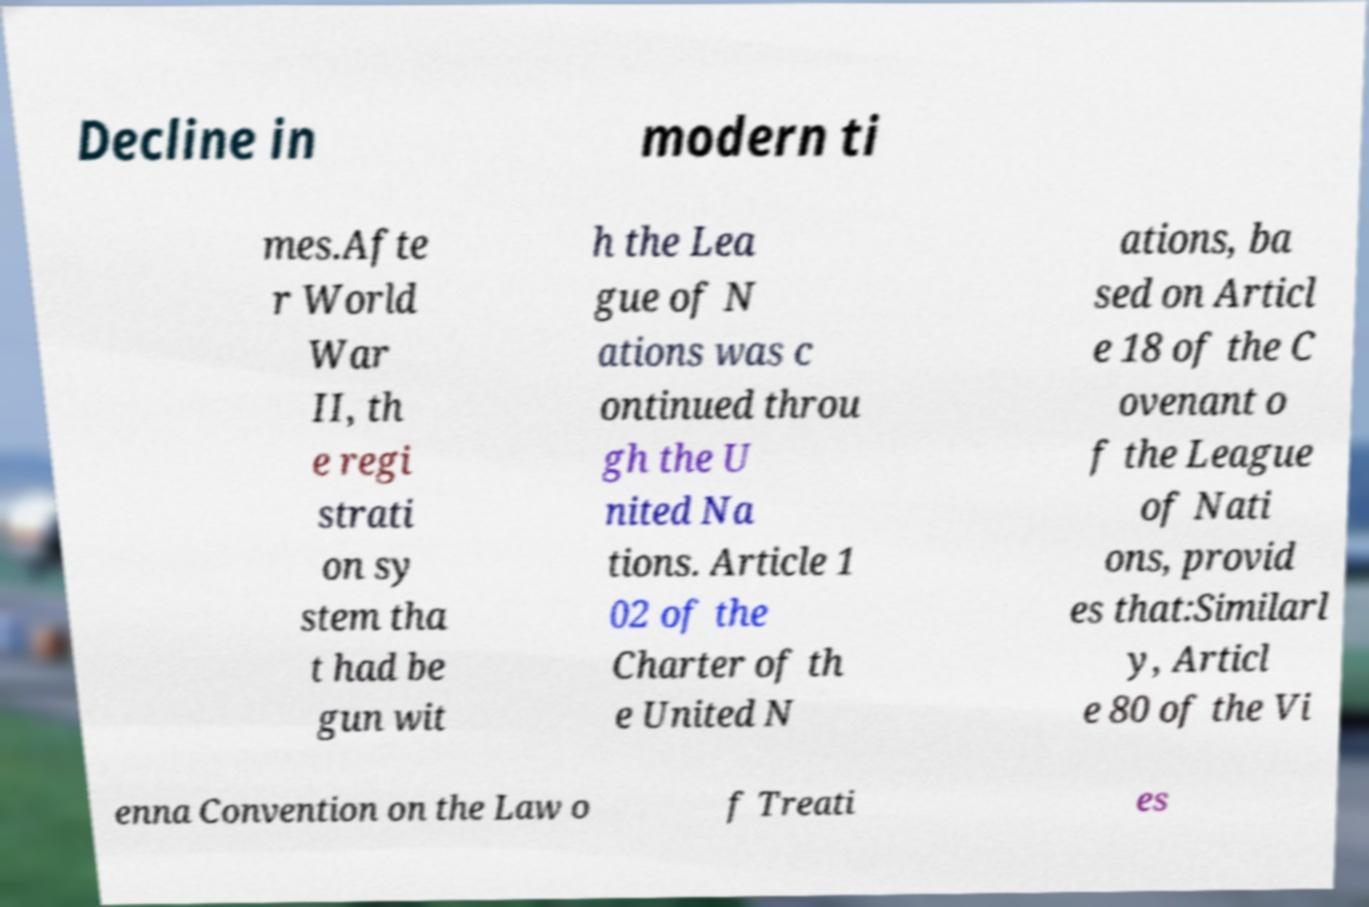Can you read and provide the text displayed in the image?This photo seems to have some interesting text. Can you extract and type it out for me? Decline in modern ti mes.Afte r World War II, th e regi strati on sy stem tha t had be gun wit h the Lea gue of N ations was c ontinued throu gh the U nited Na tions. Article 1 02 of the Charter of th e United N ations, ba sed on Articl e 18 of the C ovenant o f the League of Nati ons, provid es that:Similarl y, Articl e 80 of the Vi enna Convention on the Law o f Treati es 